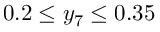Convert formula to latex. <formula><loc_0><loc_0><loc_500><loc_500>0 . 2 \leq y _ { 7 } \leq 0 . 3 5</formula> 